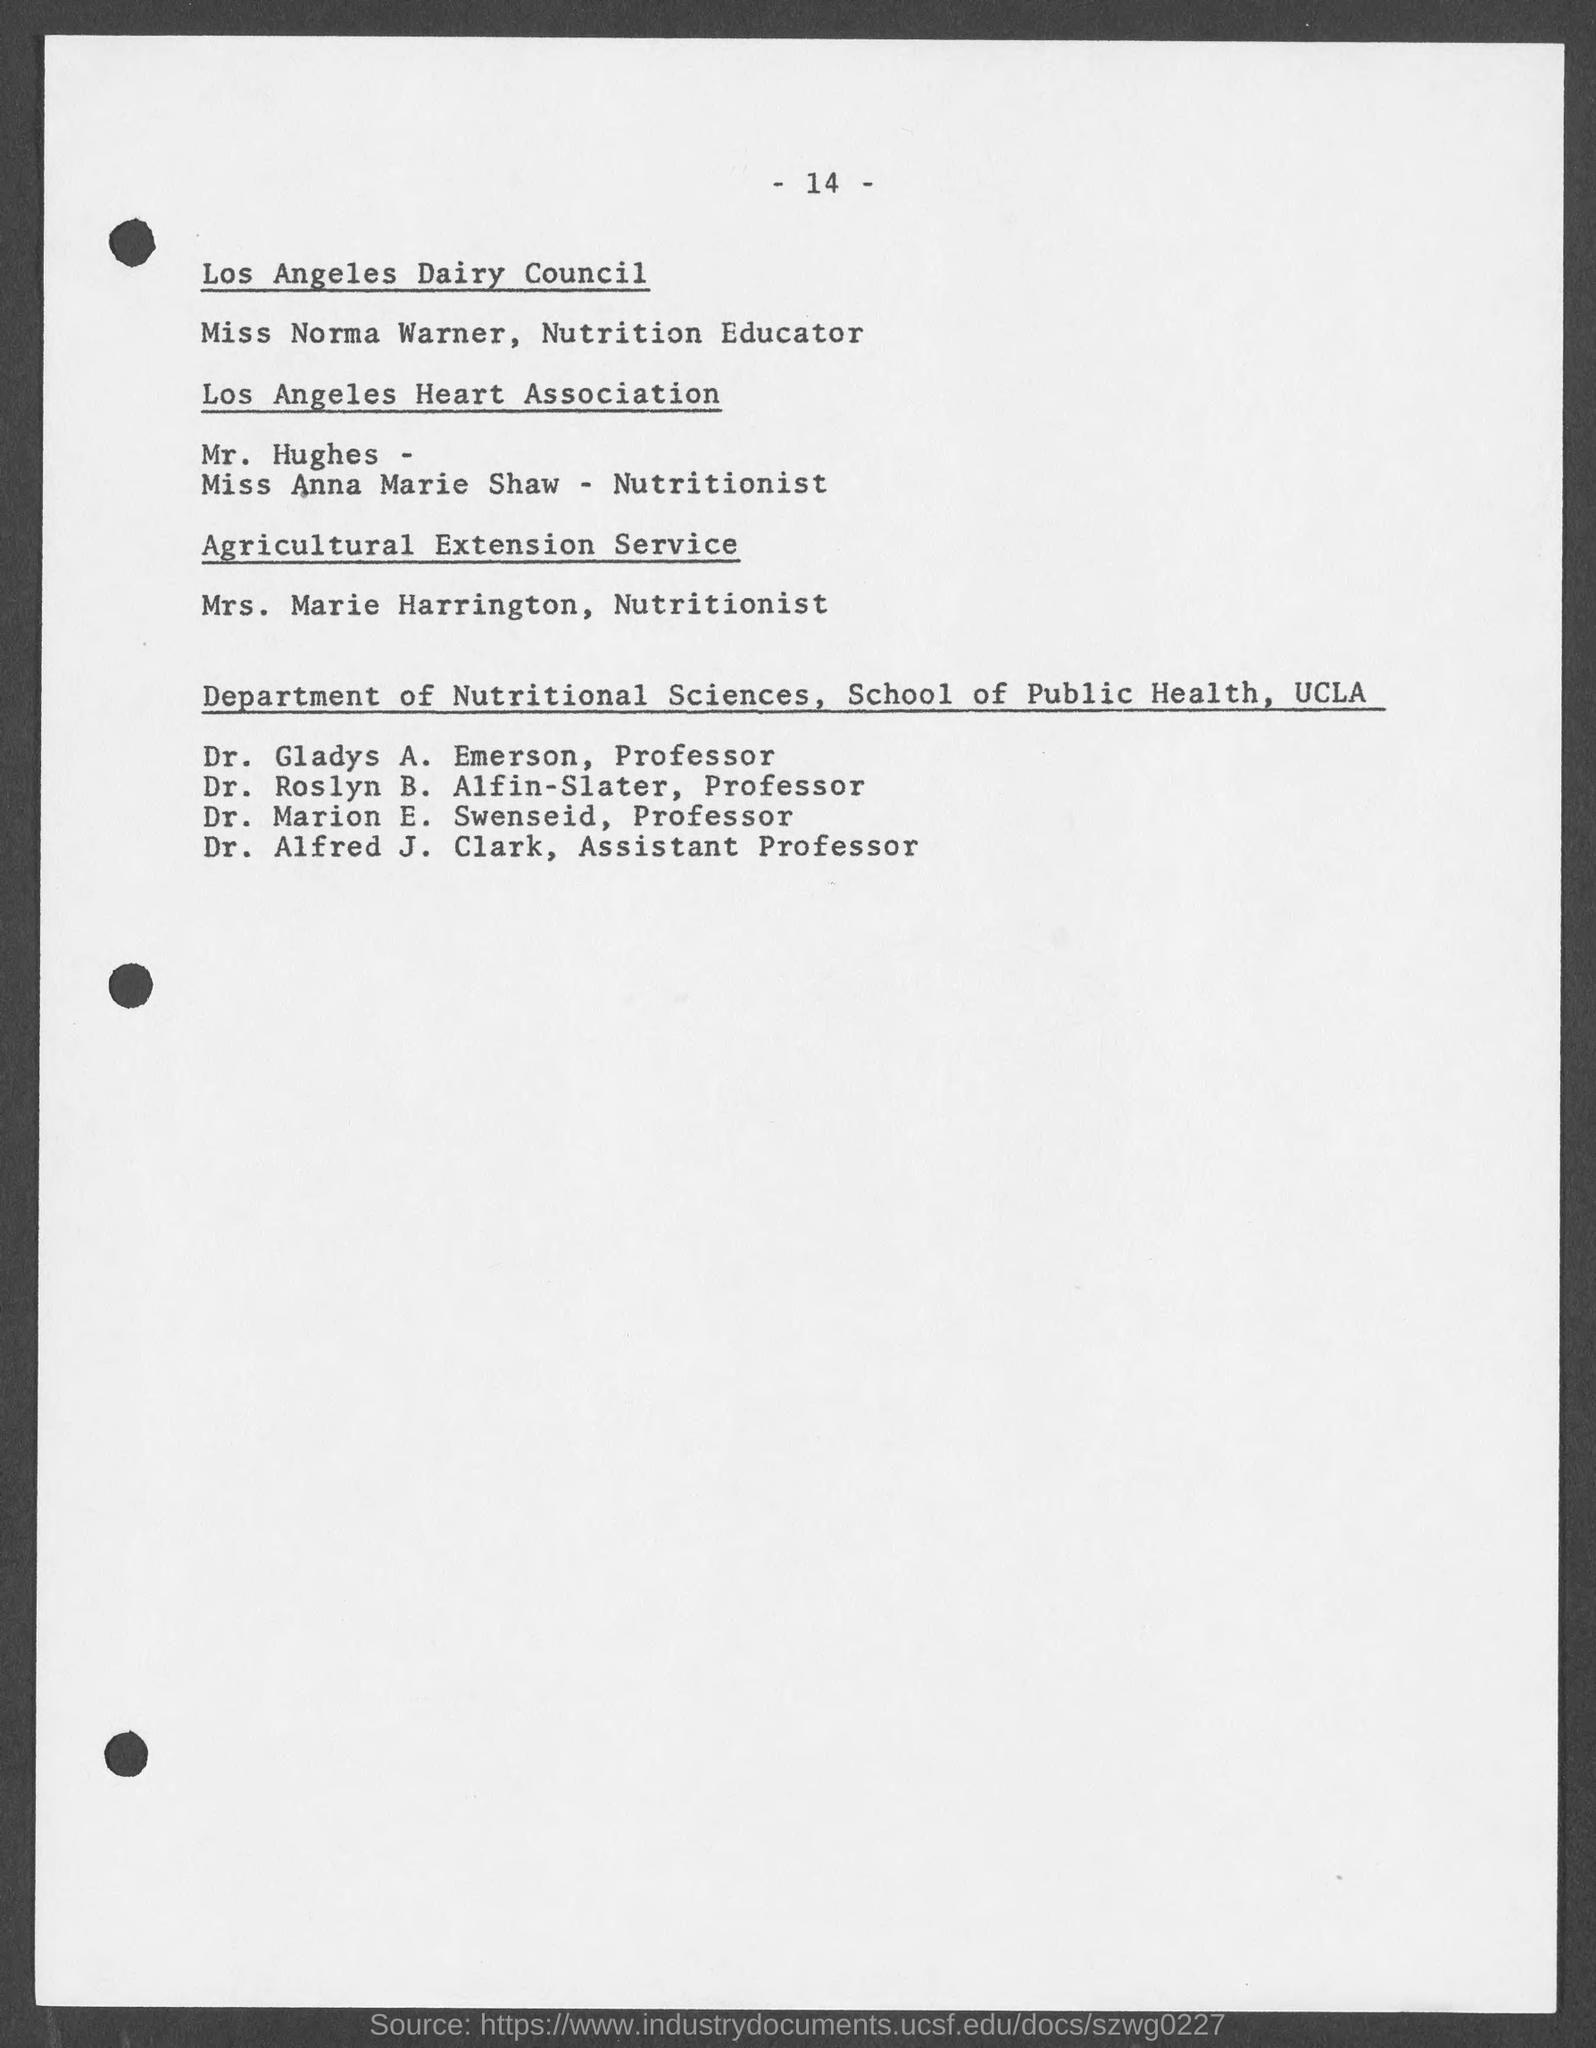List a handful of essential elements in this visual. Mrs. Marie Harrington is the nutritionist at the Agricultural Extension Service. The page number mentioned in this document is 14 -... Dr. Alfred J. Clark is an Assistant Professor in the Department of Nutritional Sciences at the School of Public Health of UCLA. 